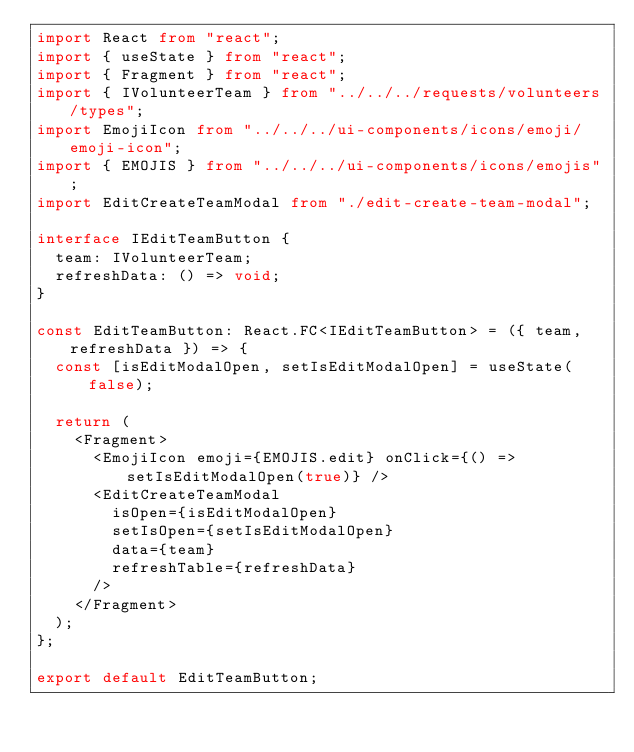Convert code to text. <code><loc_0><loc_0><loc_500><loc_500><_TypeScript_>import React from "react";
import { useState } from "react";
import { Fragment } from "react";
import { IVolunteerTeam } from "../../../requests/volunteers/types";
import EmojiIcon from "../../../ui-components/icons/emoji/emoji-icon";
import { EMOJIS } from "../../../ui-components/icons/emojis";
import EditCreateTeamModal from "./edit-create-team-modal";

interface IEditTeamButton {
  team: IVolunteerTeam;
  refreshData: () => void;
}

const EditTeamButton: React.FC<IEditTeamButton> = ({ team, refreshData }) => {
  const [isEditModalOpen, setIsEditModalOpen] = useState(false);

  return (
    <Fragment>
      <EmojiIcon emoji={EMOJIS.edit} onClick={() => setIsEditModalOpen(true)} />
      <EditCreateTeamModal
        isOpen={isEditModalOpen}
        setIsOpen={setIsEditModalOpen}
        data={team}
        refreshTable={refreshData}
      />
    </Fragment>
  );
};

export default EditTeamButton;
</code> 